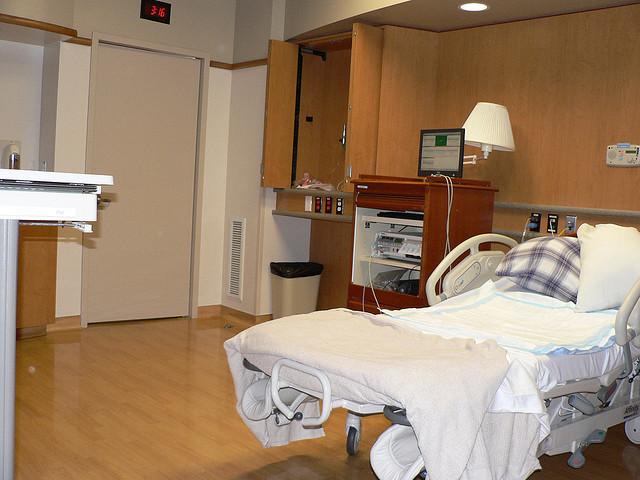Where would this room be located at?
Give a very brief answer. Hospital. What is the pattern on the pillow?
Be succinct. Plaid. Is the room empty?
Be succinct. No. 